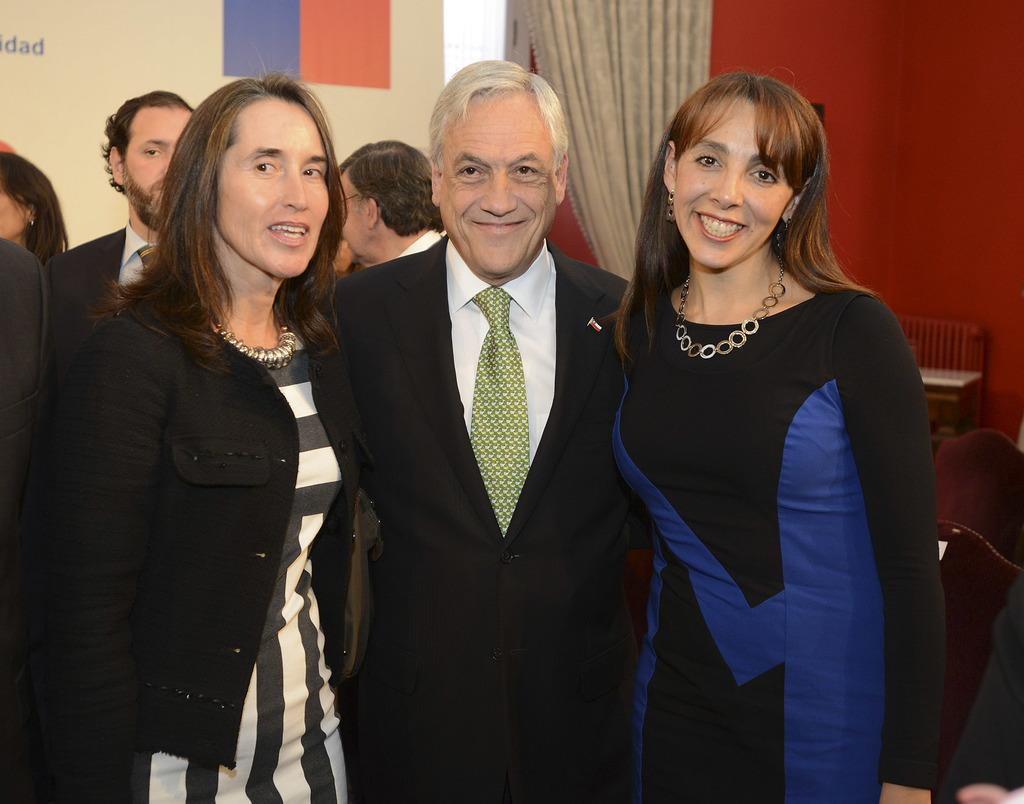How many people are in the foreground of the image? There are three persons standing in the foreground of the image. What is the facial expression of the people in the foreground? The three persons are smiling. What can be seen in the background of the image? There are other persons, a curtain, a board, a wall, and a bench in the background of the image. What type of glue is being used by the donkey in the image? There is no donkey present in the image, and therefore no glue or related activity can be observed. 